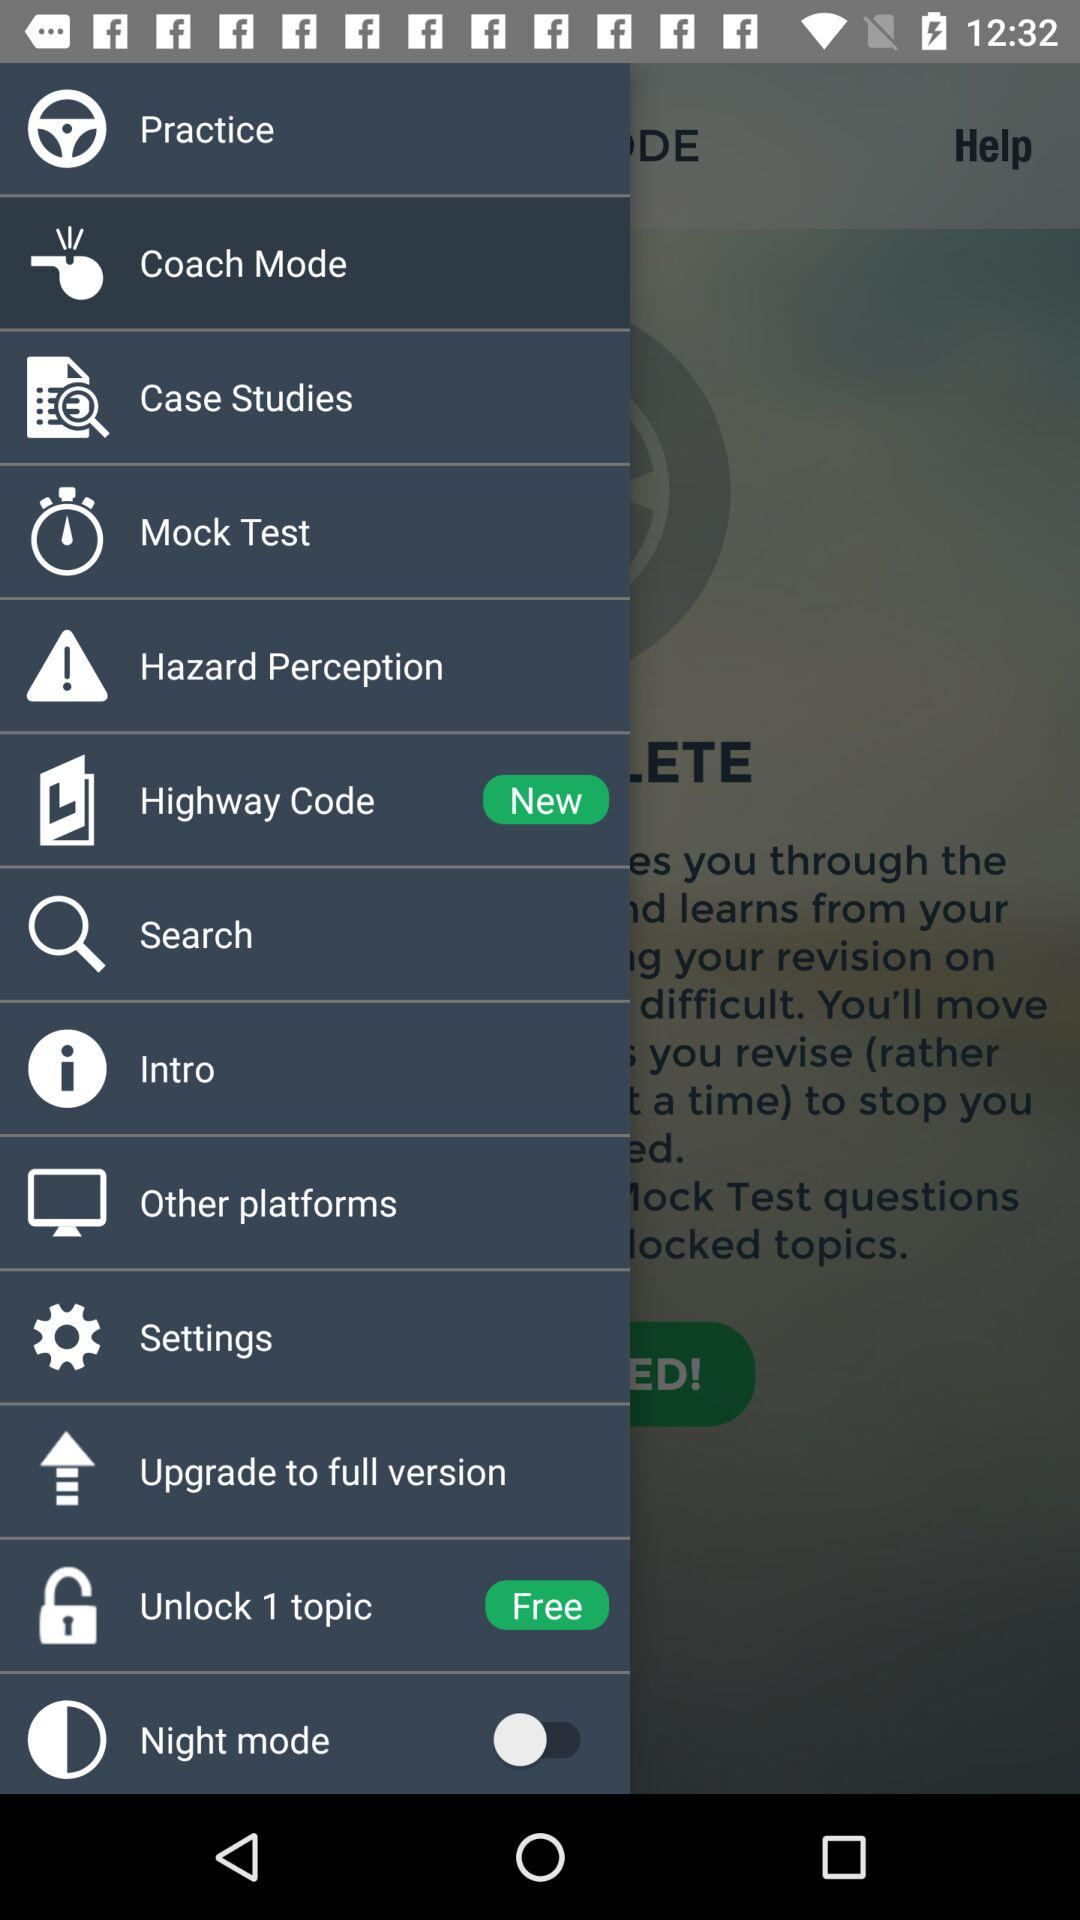What is the status of "Night mode"? The status is "off". 